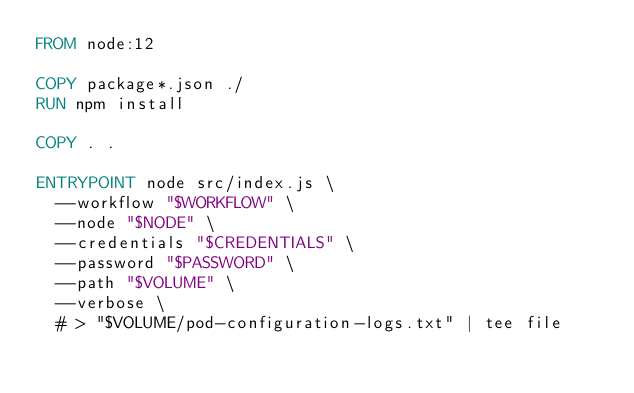Convert code to text. <code><loc_0><loc_0><loc_500><loc_500><_Dockerfile_>FROM node:12

COPY package*.json ./
RUN npm install

COPY . .

ENTRYPOINT node src/index.js \
  --workflow "$WORKFLOW" \
  --node "$NODE" \
  --credentials "$CREDENTIALS" \
  --password "$PASSWORD" \
  --path "$VOLUME" \
  --verbose \
  # > "$VOLUME/pod-configuration-logs.txt" | tee file
</code> 